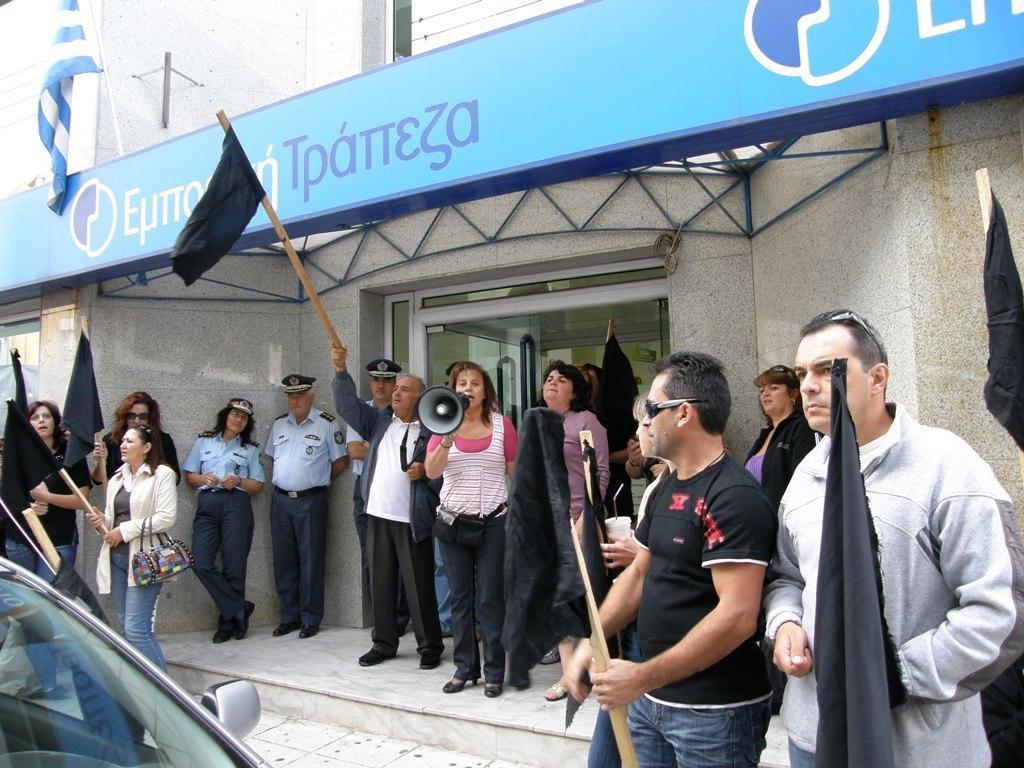In one or two sentences, can you explain what this image depicts? In the image we can see there are people standing near the building and the woman is holding loudspeaker in her hand. There are people holding flags in their hand and there is a hoarding kept on the building. There is a car parked on the road. 